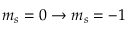<formula> <loc_0><loc_0><loc_500><loc_500>m _ { s } = 0 \rightarrow m _ { s } = - 1</formula> 